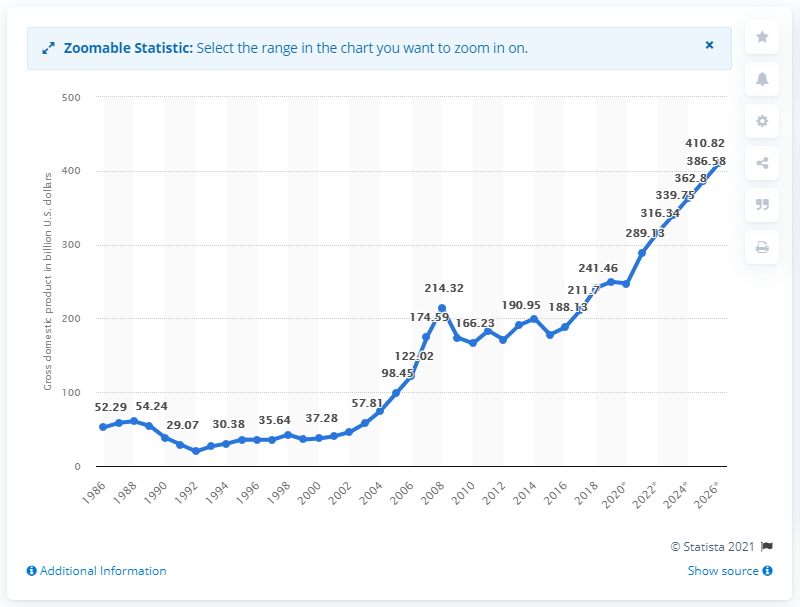Draw attention to some important aspects in this diagram. In 2019, the gross domestic product of Romania was 247.21 billion dollars. 